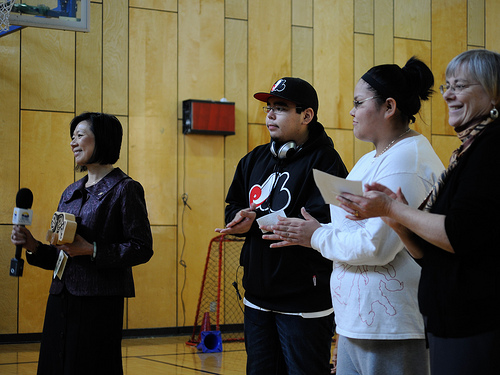<image>
Is there a mike next to the cap? No. The mike is not positioned next to the cap. They are located in different areas of the scene. 